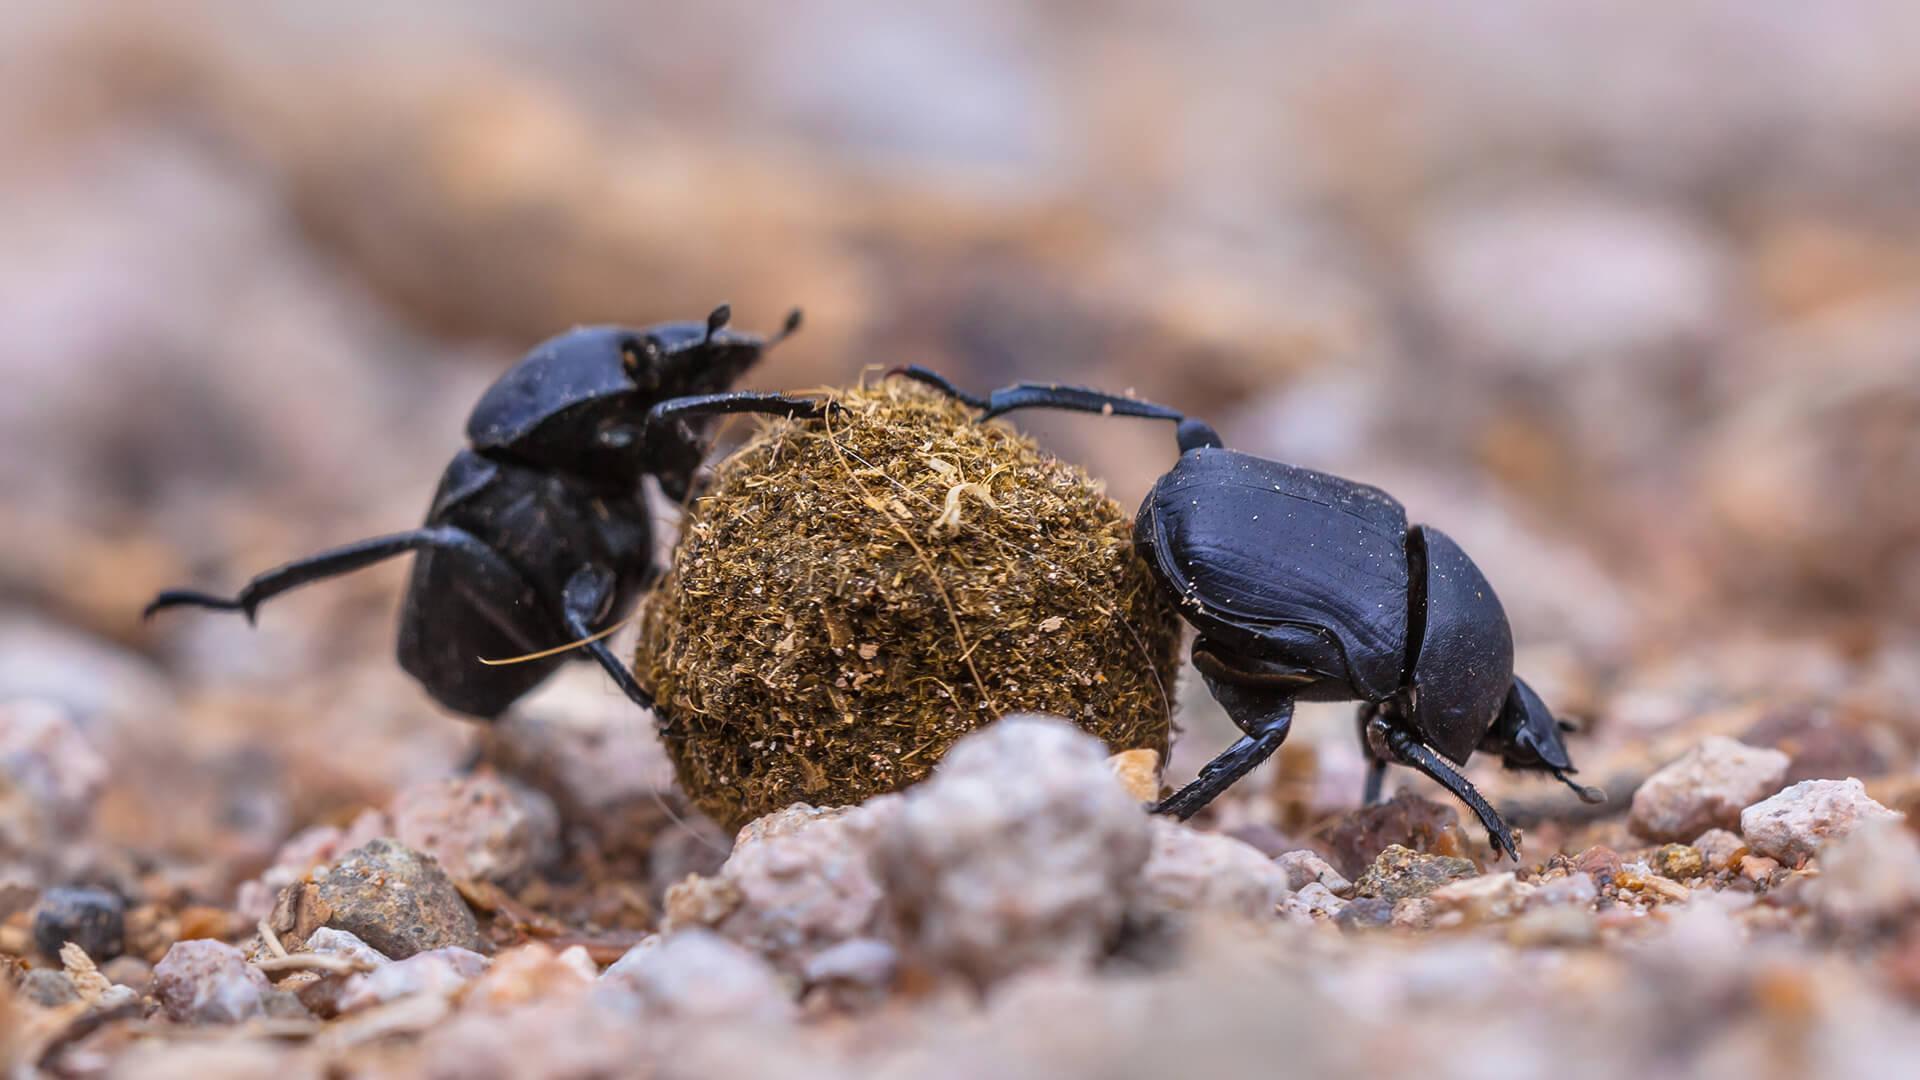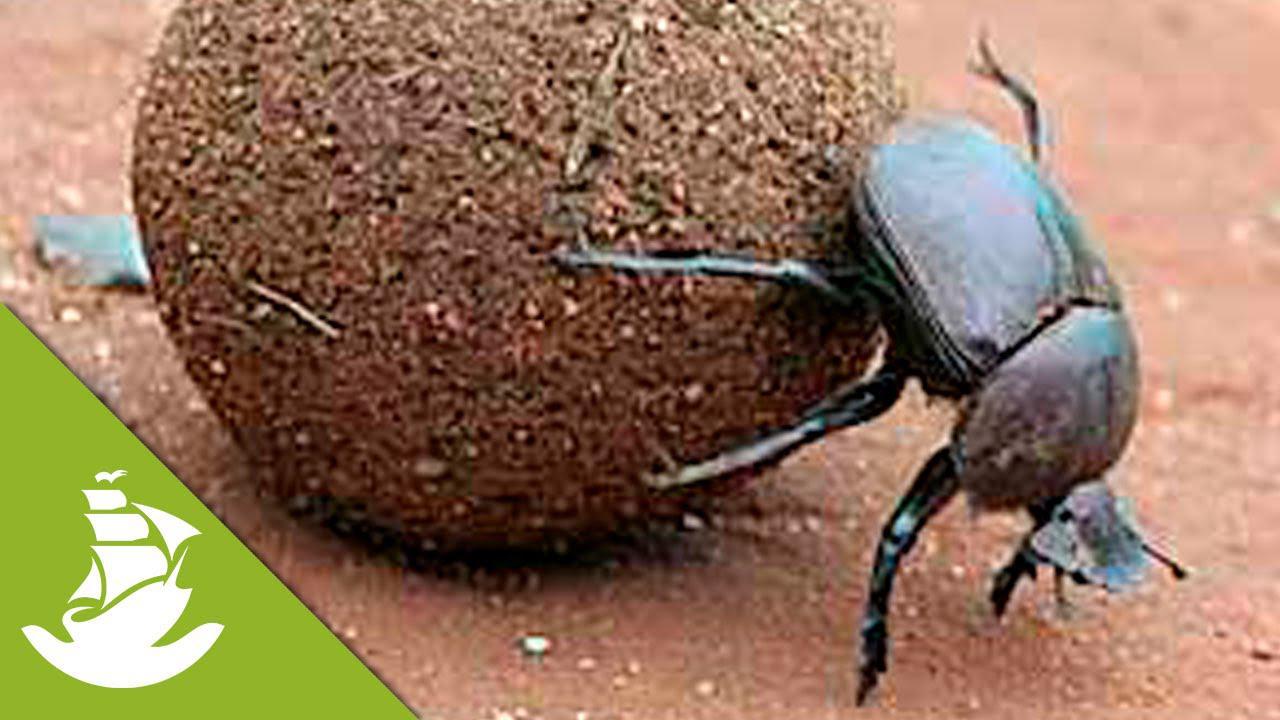The first image is the image on the left, the second image is the image on the right. Analyze the images presented: Is the assertion "There are two black dung beetles touching both the ground and the dung circle." valid? Answer yes or no. Yes. The first image is the image on the left, the second image is the image on the right. Evaluate the accuracy of this statement regarding the images: "Two beetles are near a ball of dirt in one of the images.". Is it true? Answer yes or no. Yes. The first image is the image on the left, the second image is the image on the right. For the images displayed, is the sentence "Left image shows just one beetle, with hind legs on dung ball and front legs on ground." factually correct? Answer yes or no. No. 